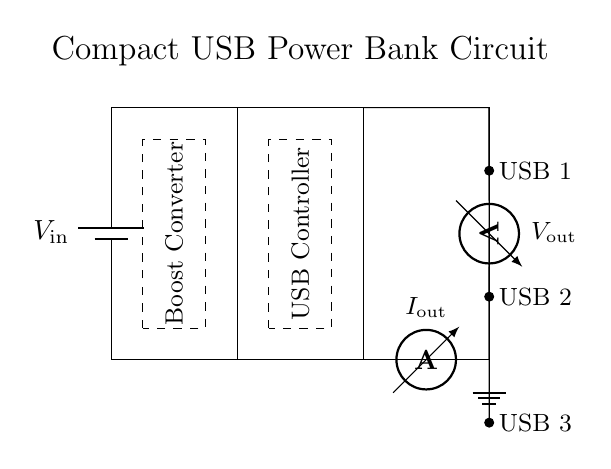What is the input voltage of the power bank? The input voltage is represented as \(V_{\text{in}}\) in the diagram, indicating the voltage supplied to the circuit.
Answer: V_in How many USB output ports are shown in the circuit? The circuit diagram clearly depicts three USB output ports labeled as USB 1, USB 2, and USB 3, confirming their presence.
Answer: 3 What component is responsible for voltage regulation? The component labeled as the "Boost Converter" is responsible for increasing the input voltage to a suitable level for output.
Answer: Boost Converter What is the function of the USB controller in this circuit? The USB controller manages the distribution of power to the multiple USB output ports, ensuring proper charging protocols are followed.
Answer: Distribution What type of current measurement is included in the circuit design? The circuit contains an ammeter, which measures the output current (\(I_{\text{out}}\)) being delivered to the USB ports.
Answer: Ammeter What is the voltage measurement point in the circuit? The voltmeter measures the output voltage (\(V_{\text{out}}\)) at the output ports, indicating the actual voltage supplied to the connected devices.
Answer: Voltmeter Explain the role of the battery in this circuit configuration. The battery serves as the primary power source, providing the necessary input voltage (\(V_{\text{in}}\)) to the rest of the circuit, enabling it to function.
Answer: Power Source 